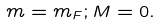Convert formula to latex. <formula><loc_0><loc_0><loc_500><loc_500>m = m _ { F } ; M = 0 .</formula> 